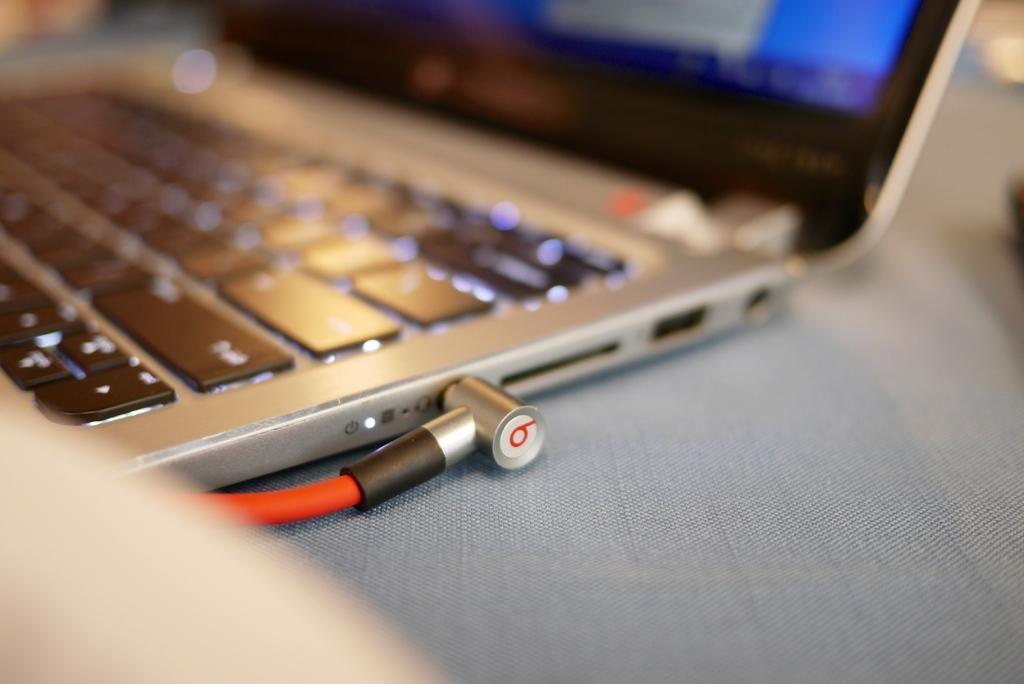<image>
Render a clear and concise summary of the photo. An orange cable labeled number 9 is plugged into a laptop. 